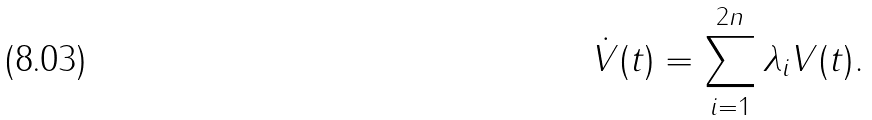<formula> <loc_0><loc_0><loc_500><loc_500>\dot { V } ( t ) = \sum _ { i = 1 } ^ { 2 n } \lambda _ { i } V ( t ) .</formula> 